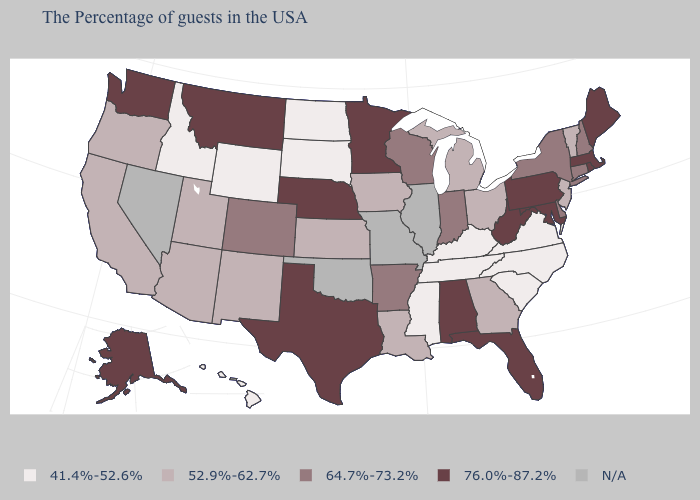What is the value of Tennessee?
Write a very short answer. 41.4%-52.6%. Name the states that have a value in the range 76.0%-87.2%?
Short answer required. Maine, Massachusetts, Rhode Island, Maryland, Pennsylvania, West Virginia, Florida, Alabama, Minnesota, Nebraska, Texas, Montana, Washington, Alaska. Name the states that have a value in the range 52.9%-62.7%?
Keep it brief. Vermont, New Jersey, Ohio, Georgia, Michigan, Louisiana, Iowa, Kansas, New Mexico, Utah, Arizona, California, Oregon. How many symbols are there in the legend?
Quick response, please. 5. What is the value of Maine?
Quick response, please. 76.0%-87.2%. Does the map have missing data?
Write a very short answer. Yes. Does Wyoming have the highest value in the West?
Be succinct. No. What is the lowest value in states that border Maine?
Short answer required. 64.7%-73.2%. What is the value of Rhode Island?
Answer briefly. 76.0%-87.2%. Name the states that have a value in the range 52.9%-62.7%?
Keep it brief. Vermont, New Jersey, Ohio, Georgia, Michigan, Louisiana, Iowa, Kansas, New Mexico, Utah, Arizona, California, Oregon. What is the lowest value in states that border Rhode Island?
Be succinct. 64.7%-73.2%. Does Nebraska have the highest value in the MidWest?
Short answer required. Yes. Among the states that border Louisiana , does Mississippi have the highest value?
Write a very short answer. No. Does Florida have the highest value in the South?
Short answer required. Yes. Which states hav the highest value in the South?
Concise answer only. Maryland, West Virginia, Florida, Alabama, Texas. 